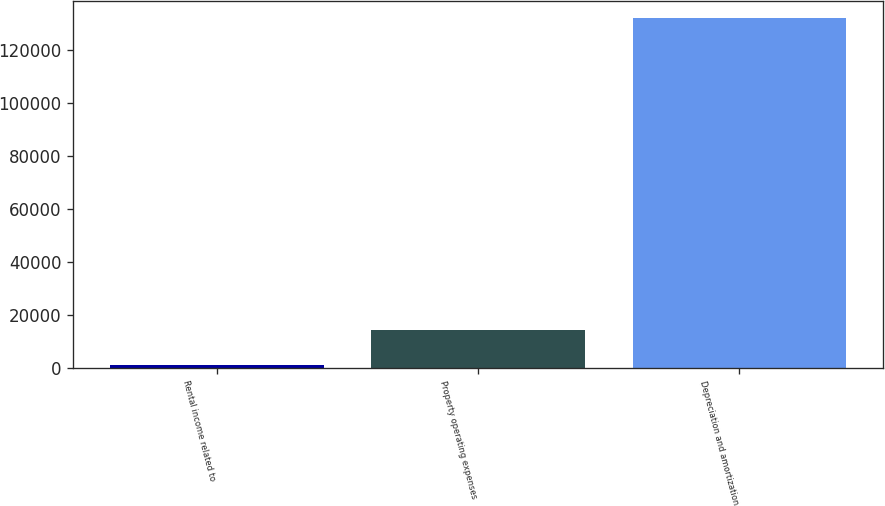Convert chart to OTSL. <chart><loc_0><loc_0><loc_500><loc_500><bar_chart><fcel>Rental income related to<fcel>Property operating expenses<fcel>Depreciation and amortization<nl><fcel>919<fcel>14041.2<fcel>132141<nl></chart> 